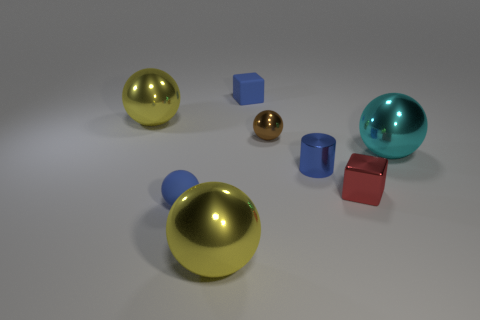What number of other objects are the same material as the brown object?
Offer a very short reply. 5. What number of objects are tiny things behind the red block or brown things?
Your answer should be very brief. 3. What is the shape of the yellow object to the left of the big shiny thing in front of the tiny red block?
Your answer should be compact. Sphere. Is the shape of the big yellow shiny object behind the big cyan ball the same as  the blue shiny thing?
Offer a terse response. No. What is the color of the cube to the left of the brown shiny sphere?
Give a very brief answer. Blue. How many balls are cyan things or small brown metal objects?
Your answer should be very brief. 2. How big is the yellow shiny thing in front of the yellow ball that is behind the metallic cylinder?
Provide a succinct answer. Large. Does the small matte cube have the same color as the cylinder in front of the big cyan object?
Offer a terse response. Yes. How many brown balls are behind the cylinder?
Make the answer very short. 1. Are there fewer brown spheres than blue things?
Offer a very short reply. Yes. 